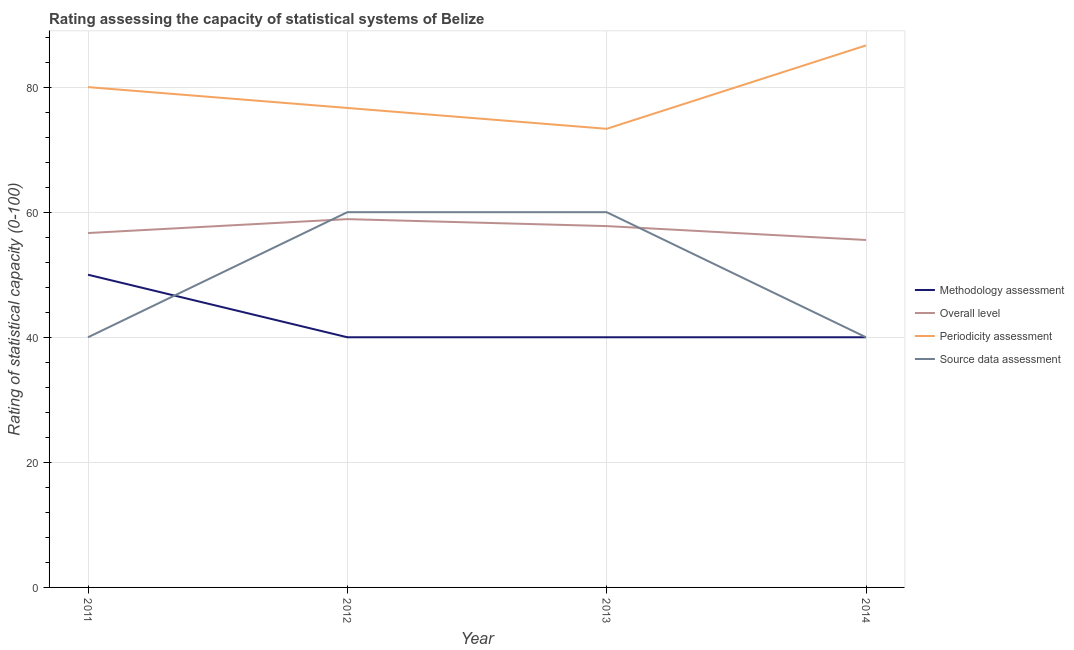How many different coloured lines are there?
Your answer should be compact. 4. Does the line corresponding to source data assessment rating intersect with the line corresponding to periodicity assessment rating?
Your response must be concise. No. What is the periodicity assessment rating in 2012?
Keep it short and to the point. 76.67. Across all years, what is the maximum periodicity assessment rating?
Ensure brevity in your answer.  86.67. Across all years, what is the minimum periodicity assessment rating?
Make the answer very short. 73.33. In which year was the source data assessment rating maximum?
Provide a succinct answer. 2012. What is the total source data assessment rating in the graph?
Make the answer very short. 200. What is the difference between the periodicity assessment rating in 2011 and that in 2013?
Your response must be concise. 6.67. What is the average methodology assessment rating per year?
Offer a very short reply. 42.5. In the year 2013, what is the difference between the source data assessment rating and methodology assessment rating?
Keep it short and to the point. 20. In how many years, is the methodology assessment rating greater than 52?
Your answer should be compact. 0. What is the ratio of the overall level rating in 2012 to that in 2014?
Your answer should be very brief. 1.06. Is the difference between the source data assessment rating in 2011 and 2013 greater than the difference between the overall level rating in 2011 and 2013?
Make the answer very short. No. What is the difference between the highest and the second highest overall level rating?
Make the answer very short. 1.11. What is the difference between the highest and the lowest periodicity assessment rating?
Give a very brief answer. 13.33. In how many years, is the periodicity assessment rating greater than the average periodicity assessment rating taken over all years?
Give a very brief answer. 2. Is the sum of the overall level rating in 2012 and 2013 greater than the maximum methodology assessment rating across all years?
Provide a short and direct response. Yes. Is it the case that in every year, the sum of the periodicity assessment rating and source data assessment rating is greater than the sum of methodology assessment rating and overall level rating?
Your answer should be compact. Yes. Is it the case that in every year, the sum of the methodology assessment rating and overall level rating is greater than the periodicity assessment rating?
Provide a short and direct response. Yes. How many years are there in the graph?
Provide a short and direct response. 4. What is the difference between two consecutive major ticks on the Y-axis?
Offer a very short reply. 20. Does the graph contain any zero values?
Keep it short and to the point. No. Does the graph contain grids?
Make the answer very short. Yes. How are the legend labels stacked?
Your answer should be compact. Vertical. What is the title of the graph?
Provide a succinct answer. Rating assessing the capacity of statistical systems of Belize. What is the label or title of the Y-axis?
Provide a succinct answer. Rating of statistical capacity (0-100). What is the Rating of statistical capacity (0-100) of Overall level in 2011?
Your answer should be very brief. 56.67. What is the Rating of statistical capacity (0-100) in Periodicity assessment in 2011?
Offer a terse response. 80. What is the Rating of statistical capacity (0-100) in Overall level in 2012?
Your response must be concise. 58.89. What is the Rating of statistical capacity (0-100) in Periodicity assessment in 2012?
Provide a succinct answer. 76.67. What is the Rating of statistical capacity (0-100) in Source data assessment in 2012?
Make the answer very short. 60. What is the Rating of statistical capacity (0-100) in Methodology assessment in 2013?
Offer a very short reply. 40. What is the Rating of statistical capacity (0-100) of Overall level in 2013?
Provide a succinct answer. 57.78. What is the Rating of statistical capacity (0-100) in Periodicity assessment in 2013?
Your answer should be compact. 73.33. What is the Rating of statistical capacity (0-100) of Overall level in 2014?
Give a very brief answer. 55.56. What is the Rating of statistical capacity (0-100) in Periodicity assessment in 2014?
Provide a short and direct response. 86.67. Across all years, what is the maximum Rating of statistical capacity (0-100) in Methodology assessment?
Provide a short and direct response. 50. Across all years, what is the maximum Rating of statistical capacity (0-100) of Overall level?
Your response must be concise. 58.89. Across all years, what is the maximum Rating of statistical capacity (0-100) in Periodicity assessment?
Keep it short and to the point. 86.67. Across all years, what is the minimum Rating of statistical capacity (0-100) of Overall level?
Give a very brief answer. 55.56. Across all years, what is the minimum Rating of statistical capacity (0-100) of Periodicity assessment?
Keep it short and to the point. 73.33. Across all years, what is the minimum Rating of statistical capacity (0-100) in Source data assessment?
Offer a very short reply. 40. What is the total Rating of statistical capacity (0-100) in Methodology assessment in the graph?
Your answer should be very brief. 170. What is the total Rating of statistical capacity (0-100) in Overall level in the graph?
Give a very brief answer. 228.89. What is the total Rating of statistical capacity (0-100) of Periodicity assessment in the graph?
Give a very brief answer. 316.67. What is the total Rating of statistical capacity (0-100) in Source data assessment in the graph?
Your answer should be very brief. 200. What is the difference between the Rating of statistical capacity (0-100) of Overall level in 2011 and that in 2012?
Make the answer very short. -2.22. What is the difference between the Rating of statistical capacity (0-100) of Periodicity assessment in 2011 and that in 2012?
Your response must be concise. 3.33. What is the difference between the Rating of statistical capacity (0-100) of Source data assessment in 2011 and that in 2012?
Give a very brief answer. -20. What is the difference between the Rating of statistical capacity (0-100) in Overall level in 2011 and that in 2013?
Ensure brevity in your answer.  -1.11. What is the difference between the Rating of statistical capacity (0-100) in Periodicity assessment in 2011 and that in 2013?
Provide a succinct answer. 6.67. What is the difference between the Rating of statistical capacity (0-100) in Source data assessment in 2011 and that in 2013?
Your answer should be very brief. -20. What is the difference between the Rating of statistical capacity (0-100) of Methodology assessment in 2011 and that in 2014?
Your response must be concise. 10. What is the difference between the Rating of statistical capacity (0-100) of Periodicity assessment in 2011 and that in 2014?
Make the answer very short. -6.67. What is the difference between the Rating of statistical capacity (0-100) of Source data assessment in 2011 and that in 2014?
Offer a terse response. 0. What is the difference between the Rating of statistical capacity (0-100) in Periodicity assessment in 2012 and that in 2013?
Provide a short and direct response. 3.33. What is the difference between the Rating of statistical capacity (0-100) in Source data assessment in 2012 and that in 2013?
Your answer should be very brief. 0. What is the difference between the Rating of statistical capacity (0-100) in Overall level in 2012 and that in 2014?
Give a very brief answer. 3.33. What is the difference between the Rating of statistical capacity (0-100) of Overall level in 2013 and that in 2014?
Provide a succinct answer. 2.22. What is the difference between the Rating of statistical capacity (0-100) in Periodicity assessment in 2013 and that in 2014?
Ensure brevity in your answer.  -13.33. What is the difference between the Rating of statistical capacity (0-100) in Source data assessment in 2013 and that in 2014?
Your response must be concise. 20. What is the difference between the Rating of statistical capacity (0-100) of Methodology assessment in 2011 and the Rating of statistical capacity (0-100) of Overall level in 2012?
Your answer should be very brief. -8.89. What is the difference between the Rating of statistical capacity (0-100) in Methodology assessment in 2011 and the Rating of statistical capacity (0-100) in Periodicity assessment in 2012?
Ensure brevity in your answer.  -26.67. What is the difference between the Rating of statistical capacity (0-100) in Methodology assessment in 2011 and the Rating of statistical capacity (0-100) in Source data assessment in 2012?
Make the answer very short. -10. What is the difference between the Rating of statistical capacity (0-100) of Overall level in 2011 and the Rating of statistical capacity (0-100) of Source data assessment in 2012?
Your answer should be very brief. -3.33. What is the difference between the Rating of statistical capacity (0-100) in Periodicity assessment in 2011 and the Rating of statistical capacity (0-100) in Source data assessment in 2012?
Ensure brevity in your answer.  20. What is the difference between the Rating of statistical capacity (0-100) of Methodology assessment in 2011 and the Rating of statistical capacity (0-100) of Overall level in 2013?
Your answer should be compact. -7.78. What is the difference between the Rating of statistical capacity (0-100) of Methodology assessment in 2011 and the Rating of statistical capacity (0-100) of Periodicity assessment in 2013?
Your answer should be compact. -23.33. What is the difference between the Rating of statistical capacity (0-100) of Overall level in 2011 and the Rating of statistical capacity (0-100) of Periodicity assessment in 2013?
Offer a terse response. -16.67. What is the difference between the Rating of statistical capacity (0-100) in Overall level in 2011 and the Rating of statistical capacity (0-100) in Source data assessment in 2013?
Keep it short and to the point. -3.33. What is the difference between the Rating of statistical capacity (0-100) in Periodicity assessment in 2011 and the Rating of statistical capacity (0-100) in Source data assessment in 2013?
Provide a succinct answer. 20. What is the difference between the Rating of statistical capacity (0-100) in Methodology assessment in 2011 and the Rating of statistical capacity (0-100) in Overall level in 2014?
Offer a terse response. -5.56. What is the difference between the Rating of statistical capacity (0-100) of Methodology assessment in 2011 and the Rating of statistical capacity (0-100) of Periodicity assessment in 2014?
Your response must be concise. -36.67. What is the difference between the Rating of statistical capacity (0-100) of Methodology assessment in 2011 and the Rating of statistical capacity (0-100) of Source data assessment in 2014?
Provide a short and direct response. 10. What is the difference between the Rating of statistical capacity (0-100) of Overall level in 2011 and the Rating of statistical capacity (0-100) of Periodicity assessment in 2014?
Provide a succinct answer. -30. What is the difference between the Rating of statistical capacity (0-100) of Overall level in 2011 and the Rating of statistical capacity (0-100) of Source data assessment in 2014?
Offer a very short reply. 16.67. What is the difference between the Rating of statistical capacity (0-100) in Periodicity assessment in 2011 and the Rating of statistical capacity (0-100) in Source data assessment in 2014?
Your answer should be compact. 40. What is the difference between the Rating of statistical capacity (0-100) in Methodology assessment in 2012 and the Rating of statistical capacity (0-100) in Overall level in 2013?
Offer a very short reply. -17.78. What is the difference between the Rating of statistical capacity (0-100) of Methodology assessment in 2012 and the Rating of statistical capacity (0-100) of Periodicity assessment in 2013?
Provide a succinct answer. -33.33. What is the difference between the Rating of statistical capacity (0-100) of Overall level in 2012 and the Rating of statistical capacity (0-100) of Periodicity assessment in 2013?
Your response must be concise. -14.44. What is the difference between the Rating of statistical capacity (0-100) of Overall level in 2012 and the Rating of statistical capacity (0-100) of Source data assessment in 2013?
Offer a terse response. -1.11. What is the difference between the Rating of statistical capacity (0-100) in Periodicity assessment in 2012 and the Rating of statistical capacity (0-100) in Source data assessment in 2013?
Your answer should be compact. 16.67. What is the difference between the Rating of statistical capacity (0-100) of Methodology assessment in 2012 and the Rating of statistical capacity (0-100) of Overall level in 2014?
Provide a short and direct response. -15.56. What is the difference between the Rating of statistical capacity (0-100) in Methodology assessment in 2012 and the Rating of statistical capacity (0-100) in Periodicity assessment in 2014?
Offer a terse response. -46.67. What is the difference between the Rating of statistical capacity (0-100) of Methodology assessment in 2012 and the Rating of statistical capacity (0-100) of Source data assessment in 2014?
Make the answer very short. 0. What is the difference between the Rating of statistical capacity (0-100) in Overall level in 2012 and the Rating of statistical capacity (0-100) in Periodicity assessment in 2014?
Provide a short and direct response. -27.78. What is the difference between the Rating of statistical capacity (0-100) of Overall level in 2012 and the Rating of statistical capacity (0-100) of Source data assessment in 2014?
Ensure brevity in your answer.  18.89. What is the difference between the Rating of statistical capacity (0-100) of Periodicity assessment in 2012 and the Rating of statistical capacity (0-100) of Source data assessment in 2014?
Offer a terse response. 36.67. What is the difference between the Rating of statistical capacity (0-100) in Methodology assessment in 2013 and the Rating of statistical capacity (0-100) in Overall level in 2014?
Your answer should be very brief. -15.56. What is the difference between the Rating of statistical capacity (0-100) in Methodology assessment in 2013 and the Rating of statistical capacity (0-100) in Periodicity assessment in 2014?
Offer a terse response. -46.67. What is the difference between the Rating of statistical capacity (0-100) in Overall level in 2013 and the Rating of statistical capacity (0-100) in Periodicity assessment in 2014?
Your response must be concise. -28.89. What is the difference between the Rating of statistical capacity (0-100) in Overall level in 2013 and the Rating of statistical capacity (0-100) in Source data assessment in 2014?
Your answer should be compact. 17.78. What is the difference between the Rating of statistical capacity (0-100) in Periodicity assessment in 2013 and the Rating of statistical capacity (0-100) in Source data assessment in 2014?
Offer a terse response. 33.33. What is the average Rating of statistical capacity (0-100) in Methodology assessment per year?
Your answer should be compact. 42.5. What is the average Rating of statistical capacity (0-100) in Overall level per year?
Make the answer very short. 57.22. What is the average Rating of statistical capacity (0-100) of Periodicity assessment per year?
Provide a succinct answer. 79.17. In the year 2011, what is the difference between the Rating of statistical capacity (0-100) in Methodology assessment and Rating of statistical capacity (0-100) in Overall level?
Your answer should be very brief. -6.67. In the year 2011, what is the difference between the Rating of statistical capacity (0-100) of Methodology assessment and Rating of statistical capacity (0-100) of Periodicity assessment?
Your answer should be compact. -30. In the year 2011, what is the difference between the Rating of statistical capacity (0-100) of Methodology assessment and Rating of statistical capacity (0-100) of Source data assessment?
Offer a very short reply. 10. In the year 2011, what is the difference between the Rating of statistical capacity (0-100) of Overall level and Rating of statistical capacity (0-100) of Periodicity assessment?
Make the answer very short. -23.33. In the year 2011, what is the difference between the Rating of statistical capacity (0-100) of Overall level and Rating of statistical capacity (0-100) of Source data assessment?
Give a very brief answer. 16.67. In the year 2012, what is the difference between the Rating of statistical capacity (0-100) in Methodology assessment and Rating of statistical capacity (0-100) in Overall level?
Your answer should be compact. -18.89. In the year 2012, what is the difference between the Rating of statistical capacity (0-100) of Methodology assessment and Rating of statistical capacity (0-100) of Periodicity assessment?
Offer a terse response. -36.67. In the year 2012, what is the difference between the Rating of statistical capacity (0-100) of Overall level and Rating of statistical capacity (0-100) of Periodicity assessment?
Your answer should be very brief. -17.78. In the year 2012, what is the difference between the Rating of statistical capacity (0-100) in Overall level and Rating of statistical capacity (0-100) in Source data assessment?
Your answer should be very brief. -1.11. In the year 2012, what is the difference between the Rating of statistical capacity (0-100) in Periodicity assessment and Rating of statistical capacity (0-100) in Source data assessment?
Offer a very short reply. 16.67. In the year 2013, what is the difference between the Rating of statistical capacity (0-100) in Methodology assessment and Rating of statistical capacity (0-100) in Overall level?
Keep it short and to the point. -17.78. In the year 2013, what is the difference between the Rating of statistical capacity (0-100) of Methodology assessment and Rating of statistical capacity (0-100) of Periodicity assessment?
Offer a terse response. -33.33. In the year 2013, what is the difference between the Rating of statistical capacity (0-100) of Methodology assessment and Rating of statistical capacity (0-100) of Source data assessment?
Your answer should be very brief. -20. In the year 2013, what is the difference between the Rating of statistical capacity (0-100) in Overall level and Rating of statistical capacity (0-100) in Periodicity assessment?
Offer a terse response. -15.56. In the year 2013, what is the difference between the Rating of statistical capacity (0-100) of Overall level and Rating of statistical capacity (0-100) of Source data assessment?
Keep it short and to the point. -2.22. In the year 2013, what is the difference between the Rating of statistical capacity (0-100) in Periodicity assessment and Rating of statistical capacity (0-100) in Source data assessment?
Your response must be concise. 13.33. In the year 2014, what is the difference between the Rating of statistical capacity (0-100) in Methodology assessment and Rating of statistical capacity (0-100) in Overall level?
Provide a succinct answer. -15.56. In the year 2014, what is the difference between the Rating of statistical capacity (0-100) in Methodology assessment and Rating of statistical capacity (0-100) in Periodicity assessment?
Your answer should be compact. -46.67. In the year 2014, what is the difference between the Rating of statistical capacity (0-100) of Overall level and Rating of statistical capacity (0-100) of Periodicity assessment?
Keep it short and to the point. -31.11. In the year 2014, what is the difference between the Rating of statistical capacity (0-100) in Overall level and Rating of statistical capacity (0-100) in Source data assessment?
Provide a succinct answer. 15.56. In the year 2014, what is the difference between the Rating of statistical capacity (0-100) of Periodicity assessment and Rating of statistical capacity (0-100) of Source data assessment?
Keep it short and to the point. 46.67. What is the ratio of the Rating of statistical capacity (0-100) in Overall level in 2011 to that in 2012?
Give a very brief answer. 0.96. What is the ratio of the Rating of statistical capacity (0-100) of Periodicity assessment in 2011 to that in 2012?
Provide a short and direct response. 1.04. What is the ratio of the Rating of statistical capacity (0-100) of Source data assessment in 2011 to that in 2012?
Offer a very short reply. 0.67. What is the ratio of the Rating of statistical capacity (0-100) of Methodology assessment in 2011 to that in 2013?
Your answer should be compact. 1.25. What is the ratio of the Rating of statistical capacity (0-100) in Overall level in 2011 to that in 2013?
Provide a succinct answer. 0.98. What is the ratio of the Rating of statistical capacity (0-100) of Methodology assessment in 2011 to that in 2014?
Offer a terse response. 1.25. What is the ratio of the Rating of statistical capacity (0-100) in Overall level in 2011 to that in 2014?
Offer a terse response. 1.02. What is the ratio of the Rating of statistical capacity (0-100) in Overall level in 2012 to that in 2013?
Offer a very short reply. 1.02. What is the ratio of the Rating of statistical capacity (0-100) in Periodicity assessment in 2012 to that in 2013?
Offer a terse response. 1.05. What is the ratio of the Rating of statistical capacity (0-100) of Overall level in 2012 to that in 2014?
Keep it short and to the point. 1.06. What is the ratio of the Rating of statistical capacity (0-100) in Periodicity assessment in 2012 to that in 2014?
Give a very brief answer. 0.88. What is the ratio of the Rating of statistical capacity (0-100) in Overall level in 2013 to that in 2014?
Your response must be concise. 1.04. What is the ratio of the Rating of statistical capacity (0-100) of Periodicity assessment in 2013 to that in 2014?
Offer a very short reply. 0.85. What is the difference between the highest and the second highest Rating of statistical capacity (0-100) of Methodology assessment?
Provide a short and direct response. 10. What is the difference between the highest and the second highest Rating of statistical capacity (0-100) of Overall level?
Keep it short and to the point. 1.11. What is the difference between the highest and the second highest Rating of statistical capacity (0-100) in Source data assessment?
Give a very brief answer. 0. What is the difference between the highest and the lowest Rating of statistical capacity (0-100) in Periodicity assessment?
Offer a terse response. 13.33. What is the difference between the highest and the lowest Rating of statistical capacity (0-100) in Source data assessment?
Offer a terse response. 20. 